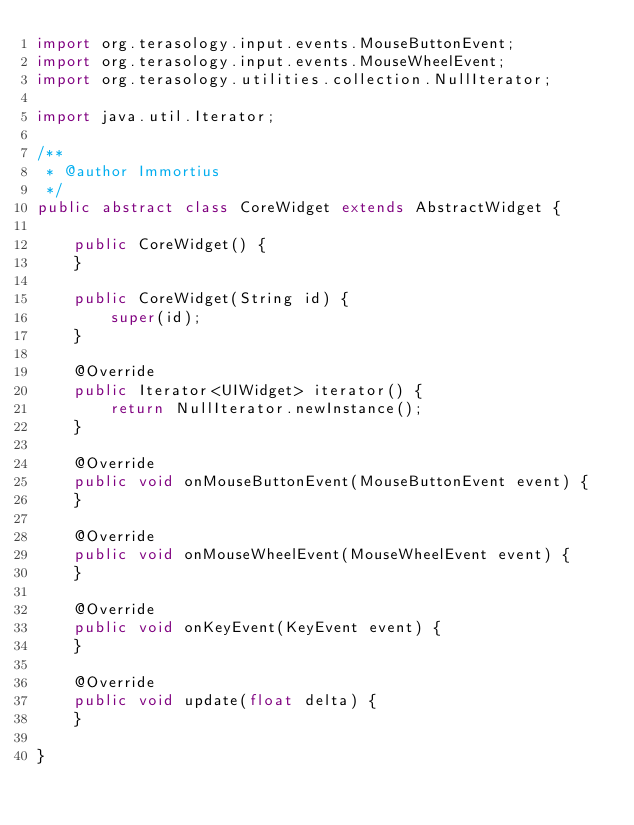Convert code to text. <code><loc_0><loc_0><loc_500><loc_500><_Java_>import org.terasology.input.events.MouseButtonEvent;
import org.terasology.input.events.MouseWheelEvent;
import org.terasology.utilities.collection.NullIterator;

import java.util.Iterator;

/**
 * @author Immortius
 */
public abstract class CoreWidget extends AbstractWidget {

    public CoreWidget() {
    }

    public CoreWidget(String id) {
        super(id);
    }

    @Override
    public Iterator<UIWidget> iterator() {
        return NullIterator.newInstance();
    }

    @Override
    public void onMouseButtonEvent(MouseButtonEvent event) {
    }

    @Override
    public void onMouseWheelEvent(MouseWheelEvent event) {
    }

    @Override
    public void onKeyEvent(KeyEvent event) {
    }

    @Override
    public void update(float delta) {
    }

}
</code> 